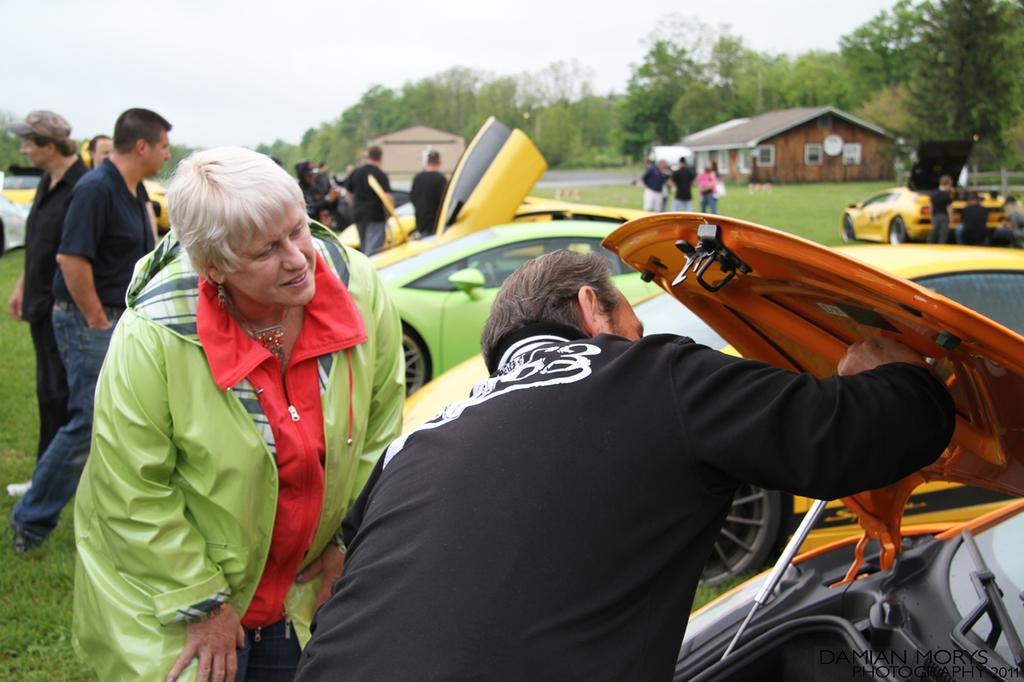What are the people in the image doing? The people in the image are standing beside cars. What can be seen in the background of the image? There is a road, trees, and the sky visible in the background of the image. What type of mark can be seen on the kite flying in the image? There is no kite present in the image, so it is not possible to determine if there is a mark on it. 